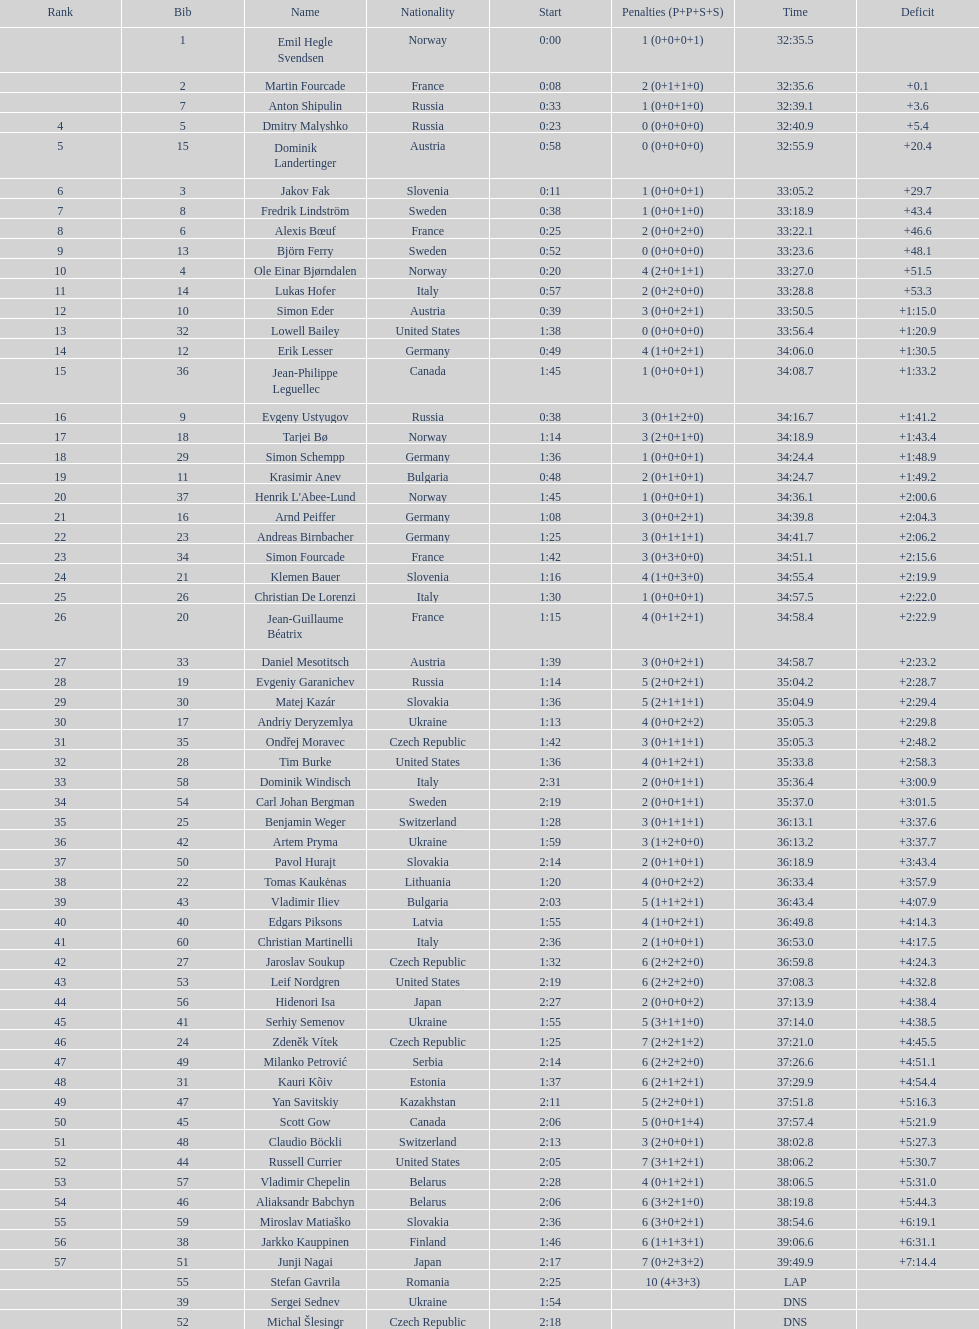What is the greatest sanction? 10. 